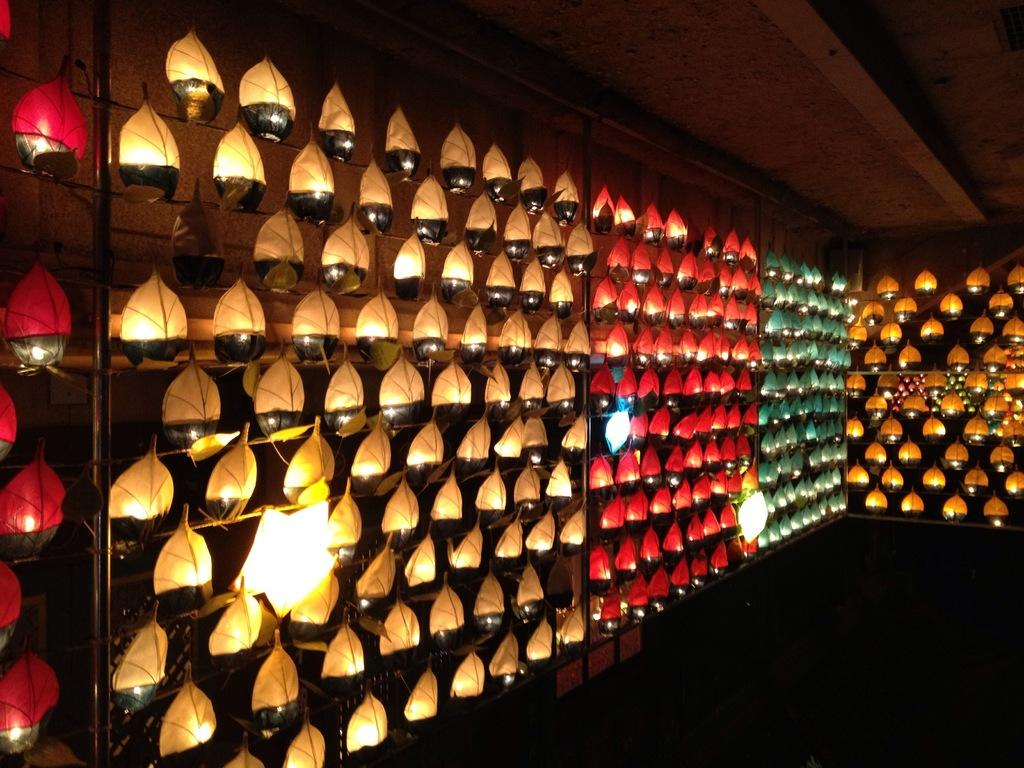What can be seen in the image? There are objects in the image. What feature do these objects have? The objects have lights. Can you describe the lights on the objects? The lights are in different colors. Where is the park located in the image? There is no park present in the image. What type of skirt is being worn by the person in the image? There is no person or skirt present in the image. 